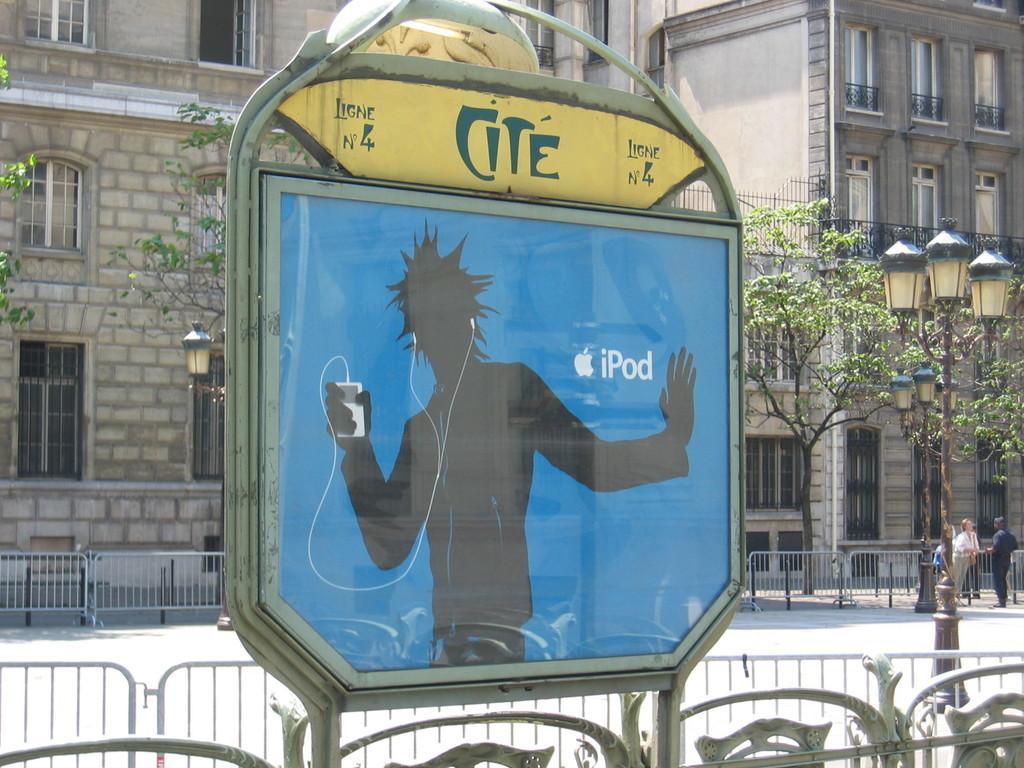Describe this image in one or two sentences. In this picture I can see a board in front and on the board I can see the depiction of a person holding a thing and I see earphones connected to it. I can also see something is written on the board. In the background I can see the railings, path, few buildings, light poles and the trees. On the right side of this picture I can see 3 persons standing. 